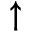<formula> <loc_0><loc_0><loc_500><loc_500>\uparrow</formula> 